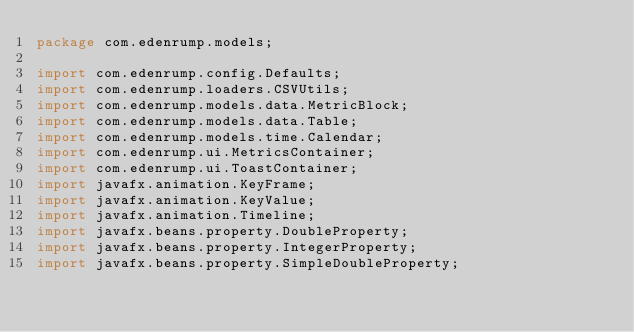Convert code to text. <code><loc_0><loc_0><loc_500><loc_500><_Java_>package com.edenrump.models;

import com.edenrump.config.Defaults;
import com.edenrump.loaders.CSVUtils;
import com.edenrump.models.data.MetricBlock;
import com.edenrump.models.data.Table;
import com.edenrump.models.time.Calendar;
import com.edenrump.ui.MetricsContainer;
import com.edenrump.ui.ToastContainer;
import javafx.animation.KeyFrame;
import javafx.animation.KeyValue;
import javafx.animation.Timeline;
import javafx.beans.property.DoubleProperty;
import javafx.beans.property.IntegerProperty;
import javafx.beans.property.SimpleDoubleProperty;</code> 